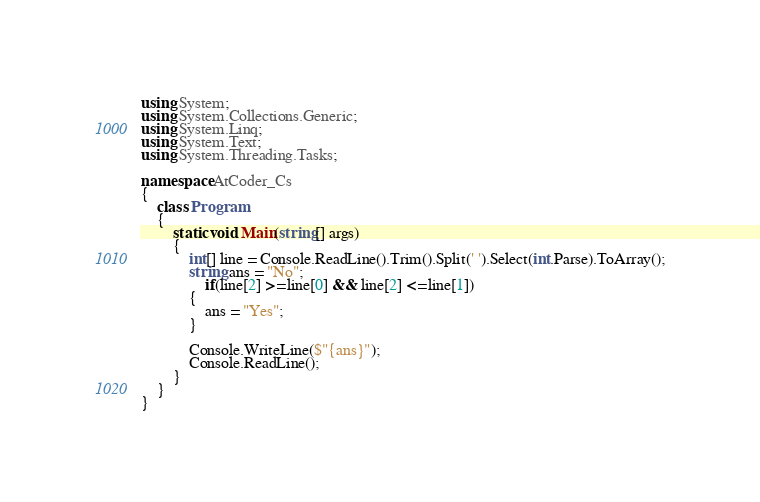Convert code to text. <code><loc_0><loc_0><loc_500><loc_500><_C#_>using System;
using System.Collections.Generic;
using System.Linq;
using System.Text;
using System.Threading.Tasks;

namespace AtCoder_Cs
{
    class Program
    {
        static void Main(string[] args)
        {
            int[] line = Console.ReadLine().Trim().Split(' ').Select(int.Parse).ToArray();
            string ans = "No";
                if(line[2] >= line[0] && line[2] <= line[1])
            {
                ans = "Yes";
            }

            Console.WriteLine($"{ans}");
            Console.ReadLine();
        }
    }
}
</code> 